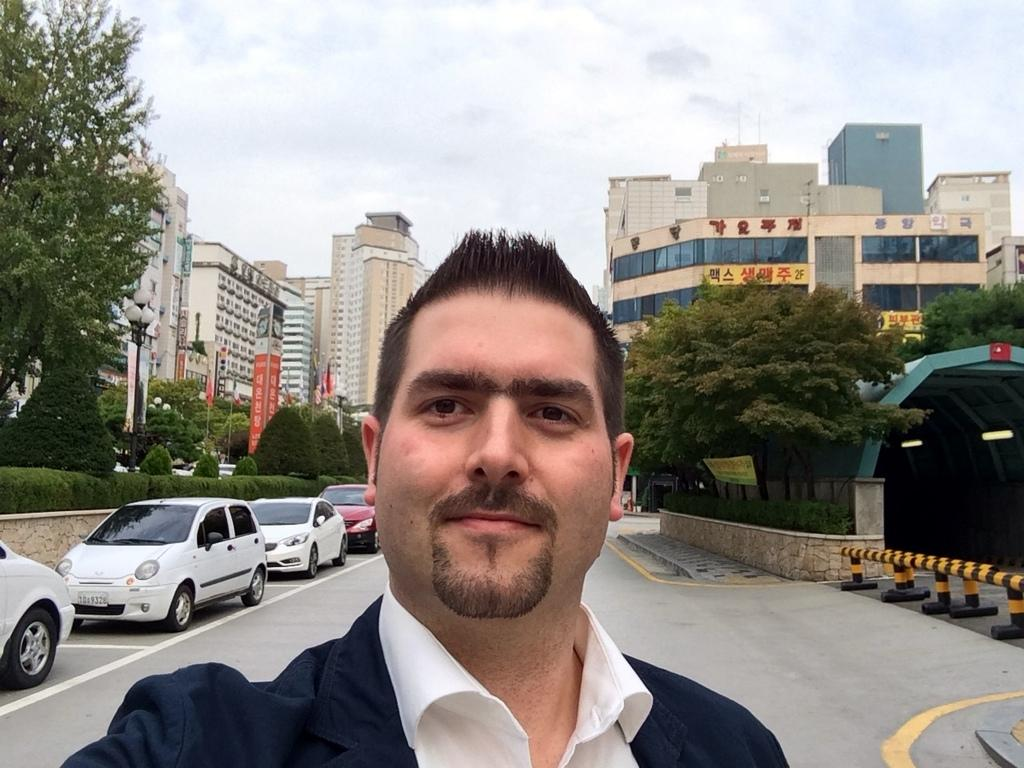Who is the main subject in the image? There is a man in the middle of the image. What is located behind the man? There are cars behind the man. What type of natural elements can be seen in the image? Trees are present in the image. What type of structures are visible in the image? Metal rods, lights, poles, hoardings, and buildings are present in the image. What type of animal is the queen riding in the image? There is no queen or animal present in the image. What is the man's hope for the future in the image? The image does not provide any information about the man's hopes or future plans. 